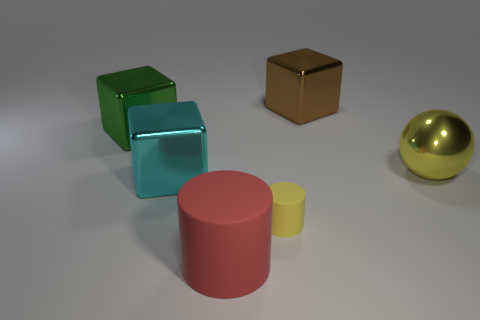Add 4 tiny brown shiny cylinders. How many objects exist? 10 Subtract all big cyan metallic blocks. How many blocks are left? 2 Subtract 1 cubes. How many cubes are left? 2 Subtract all spheres. How many objects are left? 5 Subtract all red blocks. Subtract all blue spheres. How many blocks are left? 3 Add 1 large green metal things. How many large green metal things are left? 2 Add 6 small rubber objects. How many small rubber objects exist? 7 Subtract 1 yellow cylinders. How many objects are left? 5 Subtract all large yellow objects. Subtract all red matte cylinders. How many objects are left? 4 